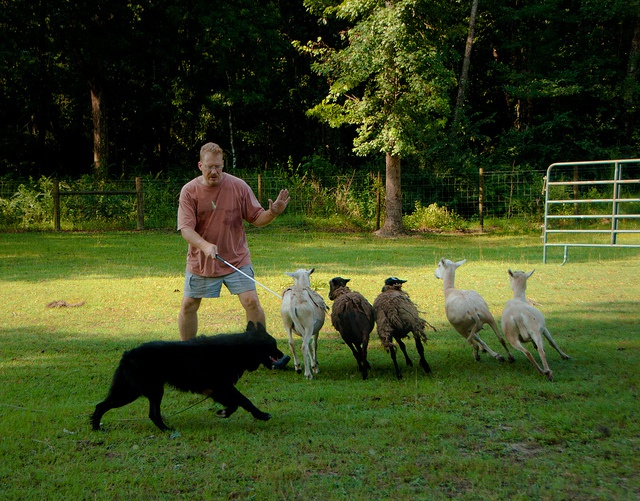Describe the objects in this image and their specific colors. I can see dog in black, darkgreen, and olive tones, people in black, maroon, and gray tones, sheep in black, darkgray, darkgreen, and gray tones, sheep in black, darkgray, and gray tones, and sheep in black, darkgray, gray, and darkgreen tones in this image. 